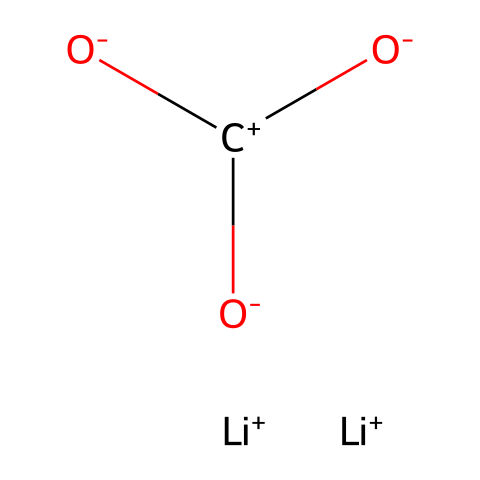What is the central atom in this chemical structure? The central atom in this chemical structure is carbon, which is represented as 'C' in the SMILES. It serves as the backbone where the hydroxyl groups are attached.
Answer: carbon How many lithium atoms are present in this structure? The SMILES representation shows two '[Li+]' species, indicating that there are two lithium atoms included in the chemical structure.
Answer: two What type of ions are present in this chemical? The presence of '+', denotes that both lithium atoms and the carbon atom are positively charged ions in this chemical structure.
Answer: cation Which functional groups can be identified in this molecule? The hydroxyl groups, indicated by '([O-])', are present around the central carbon atom, making them the functional groups in this structure.
Answer: hydroxyl groups Does this chemical contain isotopes of lithium? The SMILES representation does not specify any isotopes, but since the question pertains to isotopes of lithium, the presence of lithium indicates that the isotopes could be referenced contextually.
Answer: Yes What is the main therapeutic use of the lithium ions in this structure? Lithium ions are widely recognized for their mood-stabilizing properties, particularly effective in the treatment of bipolar disorder and mood disorders, including writer's block.
Answer: mood stabilization 